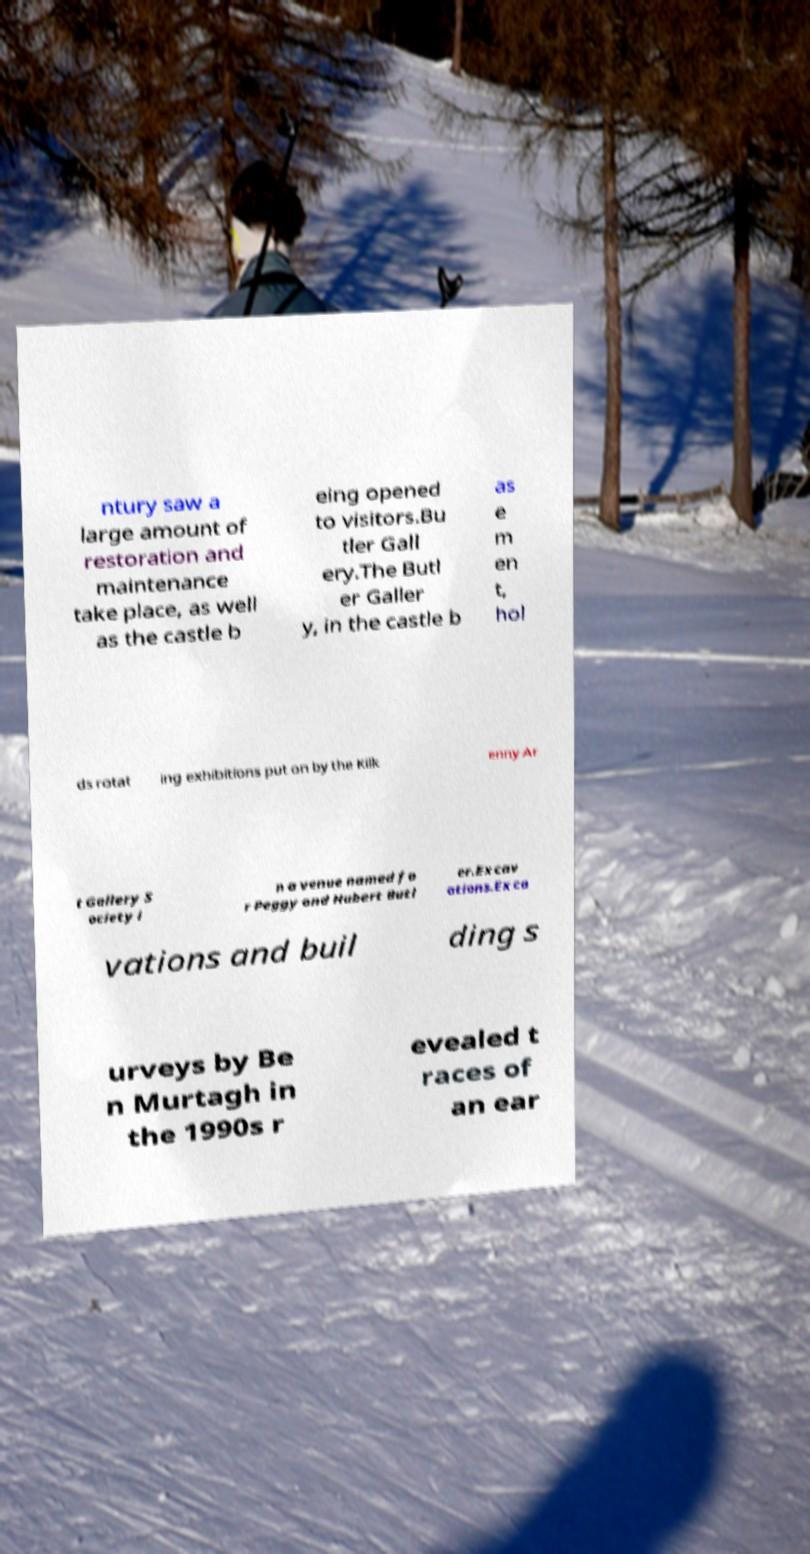Can you read and provide the text displayed in the image?This photo seems to have some interesting text. Can you extract and type it out for me? ntury saw a large amount of restoration and maintenance take place, as well as the castle b eing opened to visitors.Bu tler Gall ery.The Butl er Galler y, in the castle b as e m en t, hol ds rotat ing exhibitions put on by the Kilk enny Ar t Gallery S ociety i n a venue named fo r Peggy and Hubert Butl er.Excav ations.Exca vations and buil ding s urveys by Be n Murtagh in the 1990s r evealed t races of an ear 